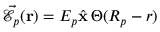Convert formula to latex. <formula><loc_0><loc_0><loc_500><loc_500>\vec { \mathcal { E } } _ { p } ( { r } ) = E _ { p } \hat { x } \, \Theta ( R _ { p } - r )</formula> 